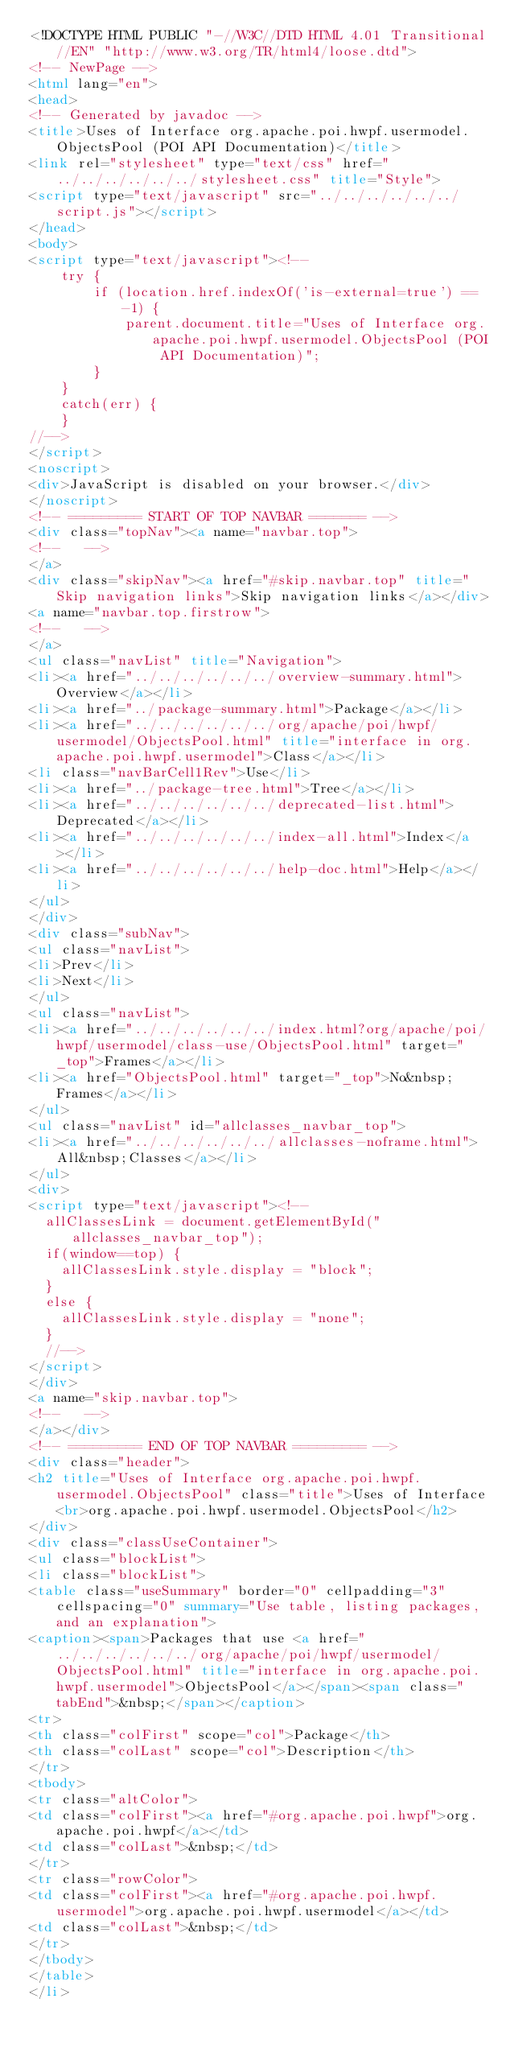Convert code to text. <code><loc_0><loc_0><loc_500><loc_500><_HTML_><!DOCTYPE HTML PUBLIC "-//W3C//DTD HTML 4.01 Transitional//EN" "http://www.w3.org/TR/html4/loose.dtd">
<!-- NewPage -->
<html lang="en">
<head>
<!-- Generated by javadoc -->
<title>Uses of Interface org.apache.poi.hwpf.usermodel.ObjectsPool (POI API Documentation)</title>
<link rel="stylesheet" type="text/css" href="../../../../../../stylesheet.css" title="Style">
<script type="text/javascript" src="../../../../../../script.js"></script>
</head>
<body>
<script type="text/javascript"><!--
    try {
        if (location.href.indexOf('is-external=true') == -1) {
            parent.document.title="Uses of Interface org.apache.poi.hwpf.usermodel.ObjectsPool (POI API Documentation)";
        }
    }
    catch(err) {
    }
//-->
</script>
<noscript>
<div>JavaScript is disabled on your browser.</div>
</noscript>
<!-- ========= START OF TOP NAVBAR ======= -->
<div class="topNav"><a name="navbar.top">
<!--   -->
</a>
<div class="skipNav"><a href="#skip.navbar.top" title="Skip navigation links">Skip navigation links</a></div>
<a name="navbar.top.firstrow">
<!--   -->
</a>
<ul class="navList" title="Navigation">
<li><a href="../../../../../../overview-summary.html">Overview</a></li>
<li><a href="../package-summary.html">Package</a></li>
<li><a href="../../../../../../org/apache/poi/hwpf/usermodel/ObjectsPool.html" title="interface in org.apache.poi.hwpf.usermodel">Class</a></li>
<li class="navBarCell1Rev">Use</li>
<li><a href="../package-tree.html">Tree</a></li>
<li><a href="../../../../../../deprecated-list.html">Deprecated</a></li>
<li><a href="../../../../../../index-all.html">Index</a></li>
<li><a href="../../../../../../help-doc.html">Help</a></li>
</ul>
</div>
<div class="subNav">
<ul class="navList">
<li>Prev</li>
<li>Next</li>
</ul>
<ul class="navList">
<li><a href="../../../../../../index.html?org/apache/poi/hwpf/usermodel/class-use/ObjectsPool.html" target="_top">Frames</a></li>
<li><a href="ObjectsPool.html" target="_top">No&nbsp;Frames</a></li>
</ul>
<ul class="navList" id="allclasses_navbar_top">
<li><a href="../../../../../../allclasses-noframe.html">All&nbsp;Classes</a></li>
</ul>
<div>
<script type="text/javascript"><!--
  allClassesLink = document.getElementById("allclasses_navbar_top");
  if(window==top) {
    allClassesLink.style.display = "block";
  }
  else {
    allClassesLink.style.display = "none";
  }
  //-->
</script>
</div>
<a name="skip.navbar.top">
<!--   -->
</a></div>
<!-- ========= END OF TOP NAVBAR ========= -->
<div class="header">
<h2 title="Uses of Interface org.apache.poi.hwpf.usermodel.ObjectsPool" class="title">Uses of Interface<br>org.apache.poi.hwpf.usermodel.ObjectsPool</h2>
</div>
<div class="classUseContainer">
<ul class="blockList">
<li class="blockList">
<table class="useSummary" border="0" cellpadding="3" cellspacing="0" summary="Use table, listing packages, and an explanation">
<caption><span>Packages that use <a href="../../../../../../org/apache/poi/hwpf/usermodel/ObjectsPool.html" title="interface in org.apache.poi.hwpf.usermodel">ObjectsPool</a></span><span class="tabEnd">&nbsp;</span></caption>
<tr>
<th class="colFirst" scope="col">Package</th>
<th class="colLast" scope="col">Description</th>
</tr>
<tbody>
<tr class="altColor">
<td class="colFirst"><a href="#org.apache.poi.hwpf">org.apache.poi.hwpf</a></td>
<td class="colLast">&nbsp;</td>
</tr>
<tr class="rowColor">
<td class="colFirst"><a href="#org.apache.poi.hwpf.usermodel">org.apache.poi.hwpf.usermodel</a></td>
<td class="colLast">&nbsp;</td>
</tr>
</tbody>
</table>
</li></code> 